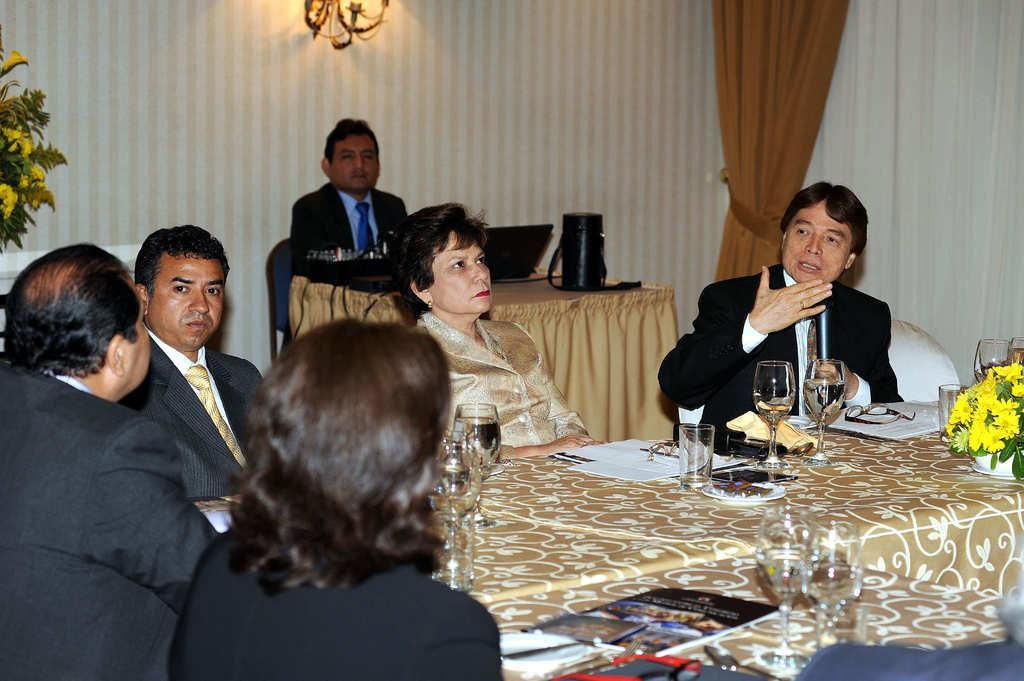In one or two sentences, can you explain what this image depicts? As we can see in the image, there is a curtain, wall, few people sitting on chairs and there is a table. On table there is a flower, glasses and papers. 